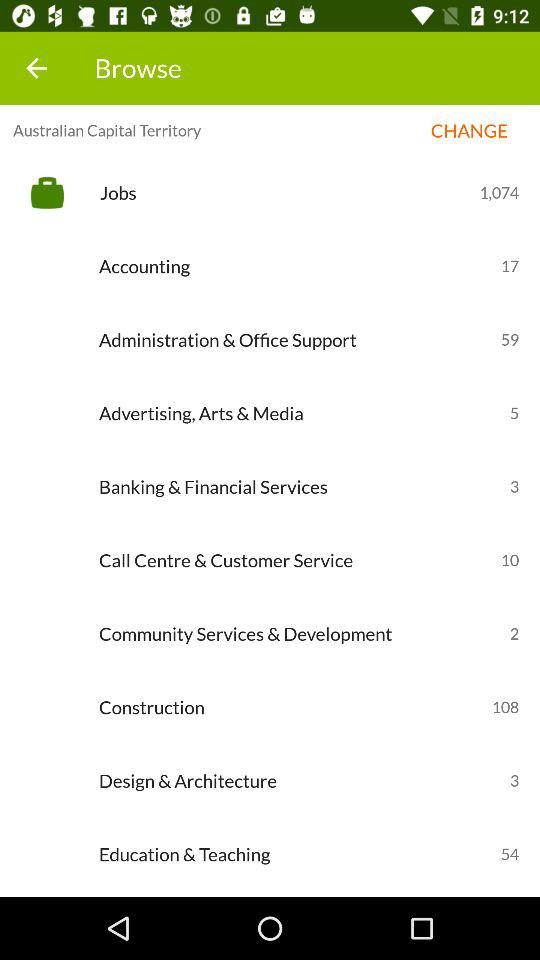How many jobs are available in the Construction category?
Answer the question using a single word or phrase. 108 